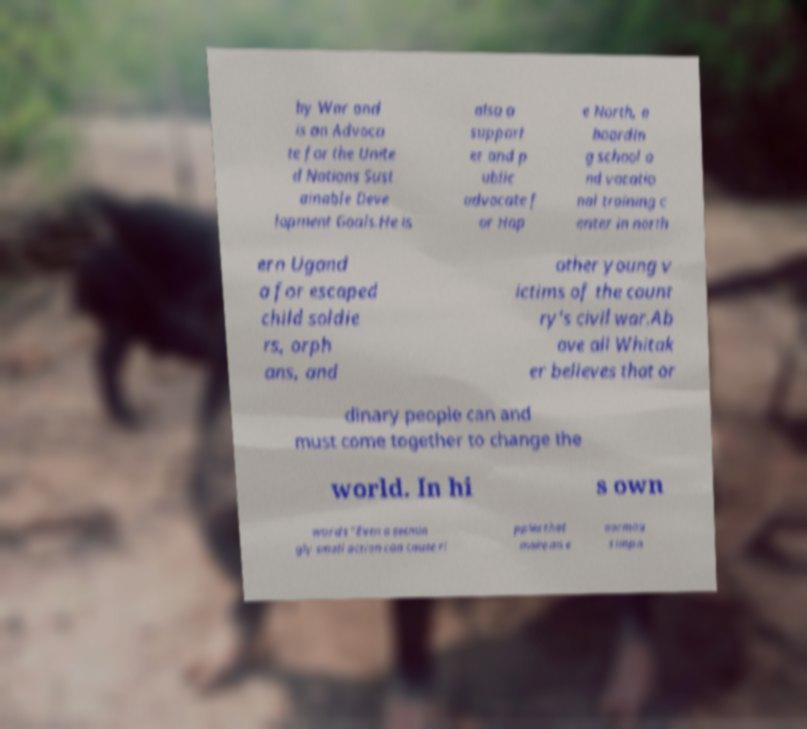What messages or text are displayed in this image? I need them in a readable, typed format. by War and is an Advoca te for the Unite d Nations Sust ainable Deve lopment Goals.He is also a support er and p ublic advocate f or Hop e North, a boardin g school a nd vocatio nal training c enter in north ern Ugand a for escaped child soldie rs, orph ans, and other young v ictims of the count ry's civil war.Ab ove all Whitak er believes that or dinary people can and must come together to change the world. In hi s own words “Even a seemin gly small action can cause ri pples that make an e normou s impa 